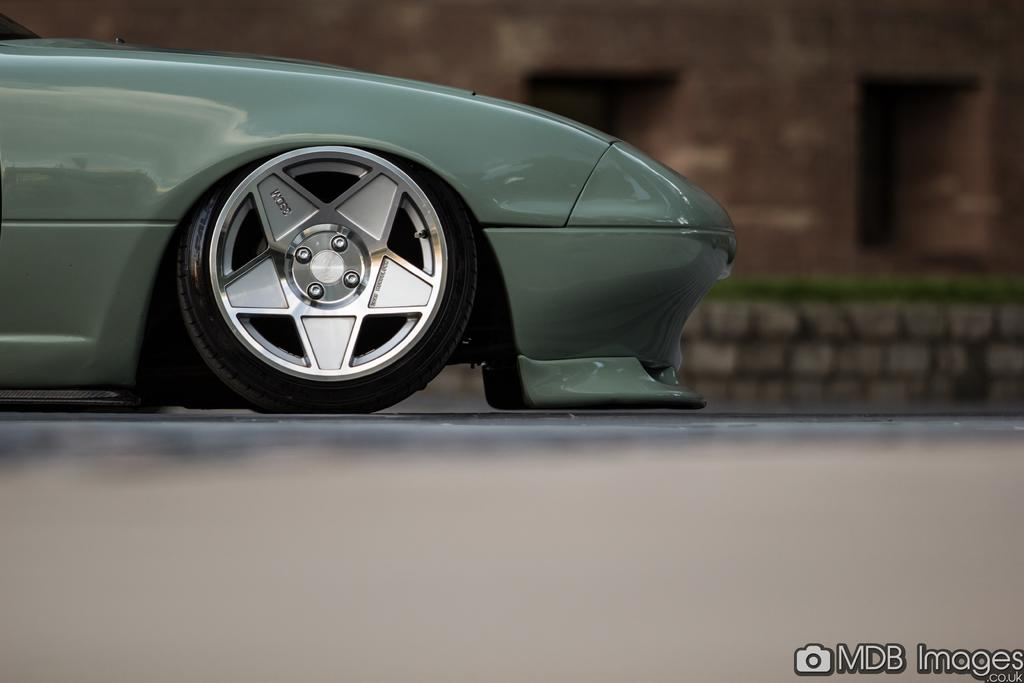What is the main subject of the image? The main subject of the image is a wheel of a vehicle on a platform. What can be seen in the background of the image? There is a wall visible in the background of the image, and there are objects present as well. Where is the text located in the image? The text is in the bottom right corner of the image. What type of family is shown playing the drum in the image? There is no family or drum present in the image; it only features a wheel of a vehicle on a platform, a wall in the background, and text in the bottom right corner. What song is being played by the musicians in the image? There are no musicians or songs present in the image. 